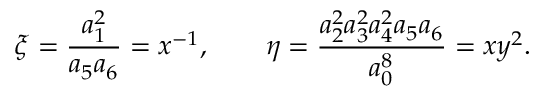Convert formula to latex. <formula><loc_0><loc_0><loc_500><loc_500>\xi = \frac { a _ { 1 } ^ { 2 } } { a _ { 5 } a _ { 6 } } = x ^ { - 1 } , \quad \eta = \frac { a _ { 2 } ^ { 2 } a _ { 3 } ^ { 2 } a _ { 4 } ^ { 2 } a _ { 5 } a _ { 6 } } { a _ { 0 } ^ { 8 } } = x y ^ { 2 } .</formula> 